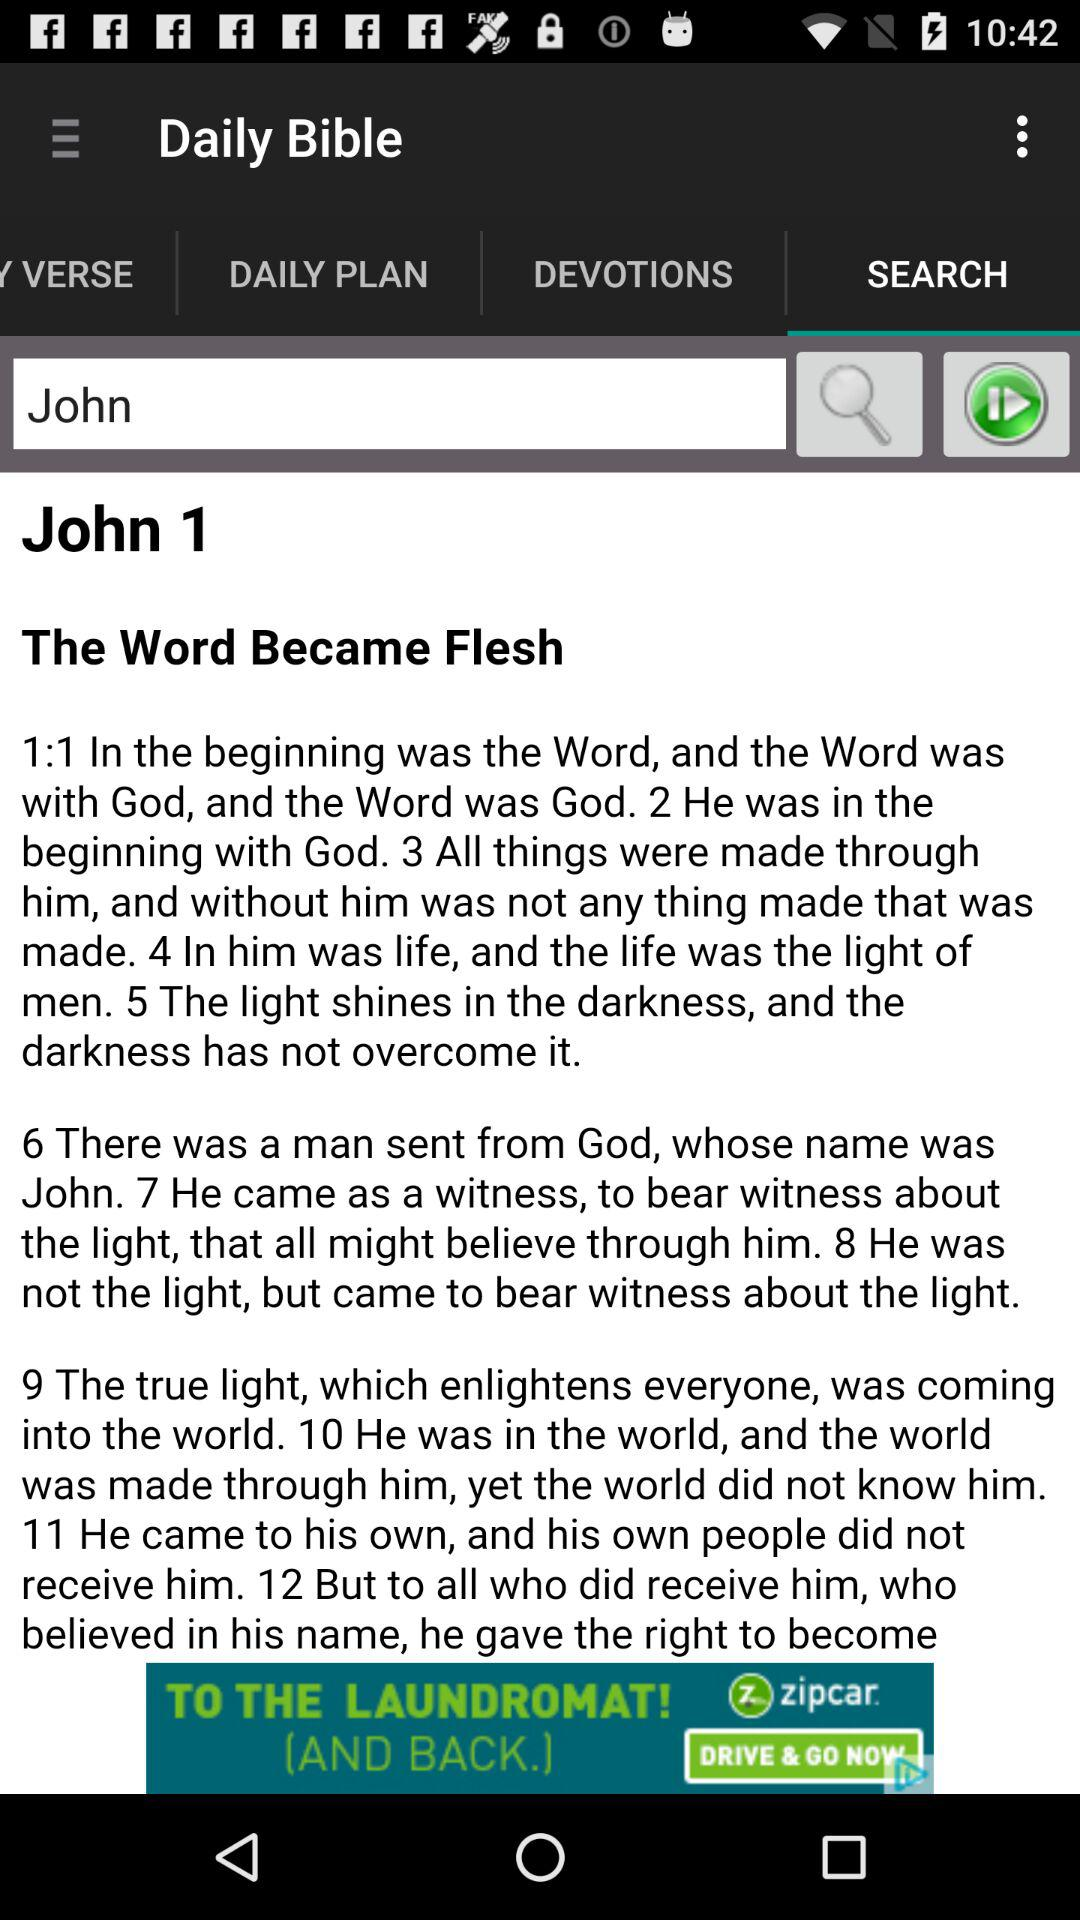What is in the beginning? At the beginning, there is a "Word". 